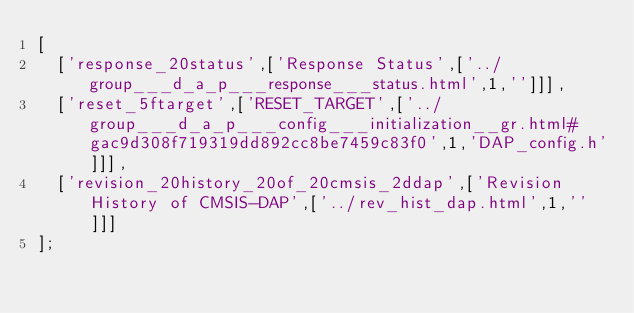Convert code to text. <code><loc_0><loc_0><loc_500><loc_500><_JavaScript_>[
  ['response_20status',['Response Status',['../group___d_a_p___response___status.html',1,'']]],
  ['reset_5ftarget',['RESET_TARGET',['../group___d_a_p___config___initialization__gr.html#gac9d308f719319dd892cc8be7459c83f0',1,'DAP_config.h']]],
  ['revision_20history_20of_20cmsis_2ddap',['Revision History of CMSIS-DAP',['../rev_hist_dap.html',1,'']]]
];
</code> 